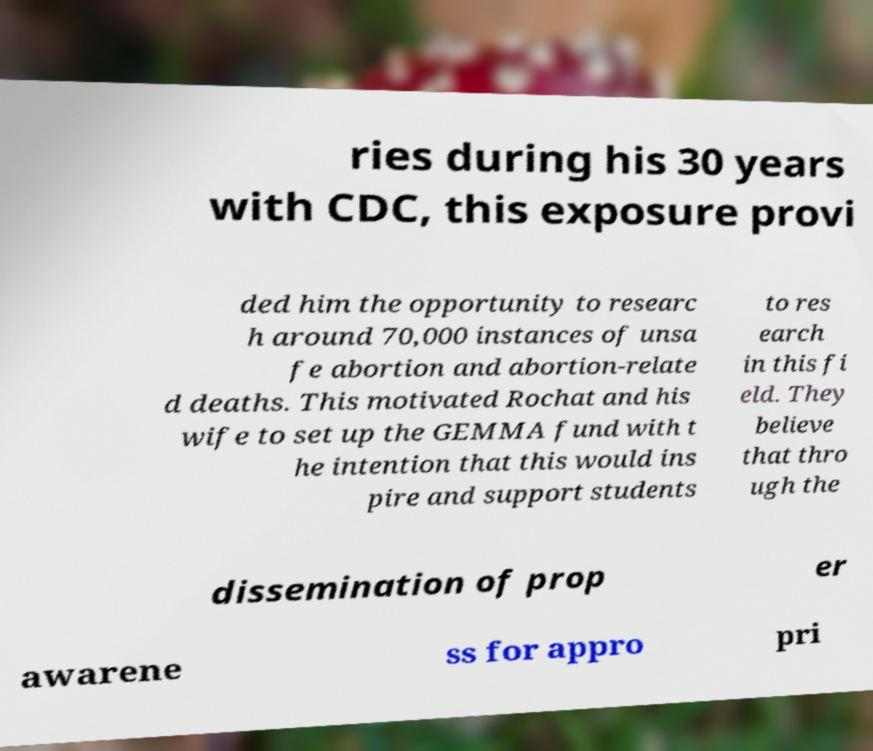For documentation purposes, I need the text within this image transcribed. Could you provide that? ries during his 30 years with CDC, this exposure provi ded him the opportunity to researc h around 70,000 instances of unsa fe abortion and abortion-relate d deaths. This motivated Rochat and his wife to set up the GEMMA fund with t he intention that this would ins pire and support students to res earch in this fi eld. They believe that thro ugh the dissemination of prop er awarene ss for appro pri 